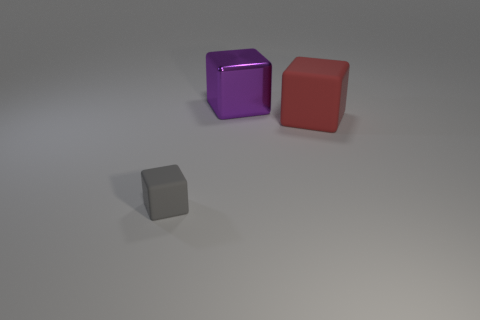Add 1 large cyan shiny blocks. How many objects exist? 4 Add 3 large purple cubes. How many large purple cubes exist? 4 Subtract 0 cyan cylinders. How many objects are left? 3 Subtract all large metal cubes. Subtract all large purple shiny things. How many objects are left? 1 Add 2 small gray matte objects. How many small gray matte objects are left? 3 